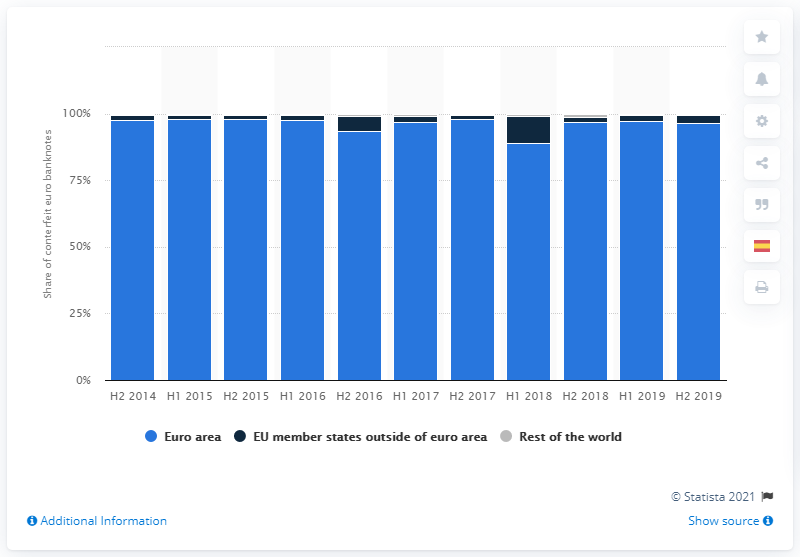Give some essential details in this illustration. In the second half of 2019, 96.4% of counterfeit euro notes were withdrawn from circulation in euro area countries. 